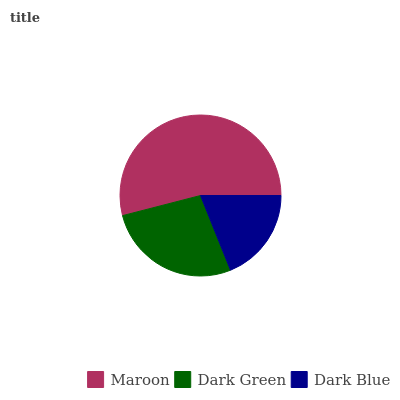Is Dark Blue the minimum?
Answer yes or no. Yes. Is Maroon the maximum?
Answer yes or no. Yes. Is Dark Green the minimum?
Answer yes or no. No. Is Dark Green the maximum?
Answer yes or no. No. Is Maroon greater than Dark Green?
Answer yes or no. Yes. Is Dark Green less than Maroon?
Answer yes or no. Yes. Is Dark Green greater than Maroon?
Answer yes or no. No. Is Maroon less than Dark Green?
Answer yes or no. No. Is Dark Green the high median?
Answer yes or no. Yes. Is Dark Green the low median?
Answer yes or no. Yes. Is Maroon the high median?
Answer yes or no. No. Is Dark Blue the low median?
Answer yes or no. No. 